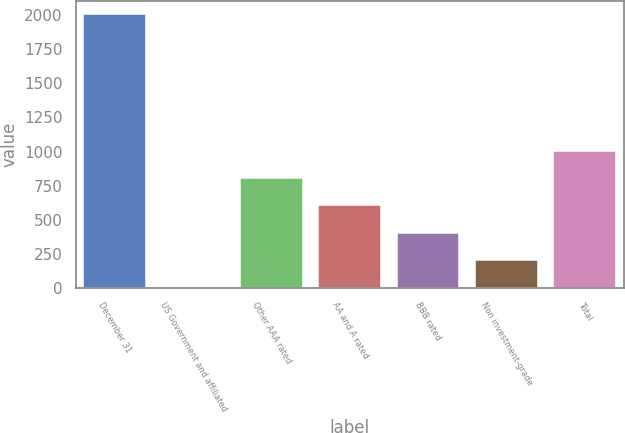Convert chart to OTSL. <chart><loc_0><loc_0><loc_500><loc_500><bar_chart><fcel>December 31<fcel>US Government and affiliated<fcel>Other AAA rated<fcel>AA and A rated<fcel>BBB rated<fcel>Non investment-grade<fcel>Total<nl><fcel>2007<fcel>2.5<fcel>804.3<fcel>603.85<fcel>403.4<fcel>202.95<fcel>1004.75<nl></chart> 